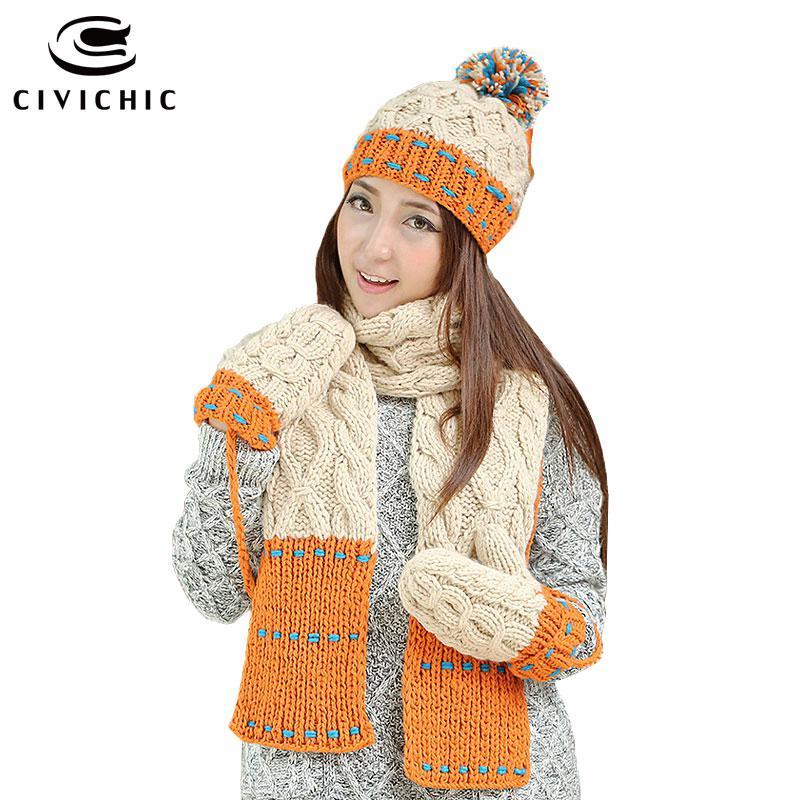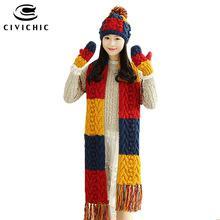The first image is the image on the left, the second image is the image on the right. For the images displayed, is the sentence "A young girl is wearing a matching scarf, hat and gloves set that is white, brown and pink." factually correct? Answer yes or no. No. The first image is the image on the left, the second image is the image on the right. Given the left and right images, does the statement "there is a girl with a scarf covering the bottom half of her face" hold true? Answer yes or no. No. 